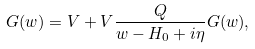Convert formula to latex. <formula><loc_0><loc_0><loc_500><loc_500>G ( w ) = V + V \frac { Q } { w - H _ { 0 } + i \eta } G ( w ) ,</formula> 